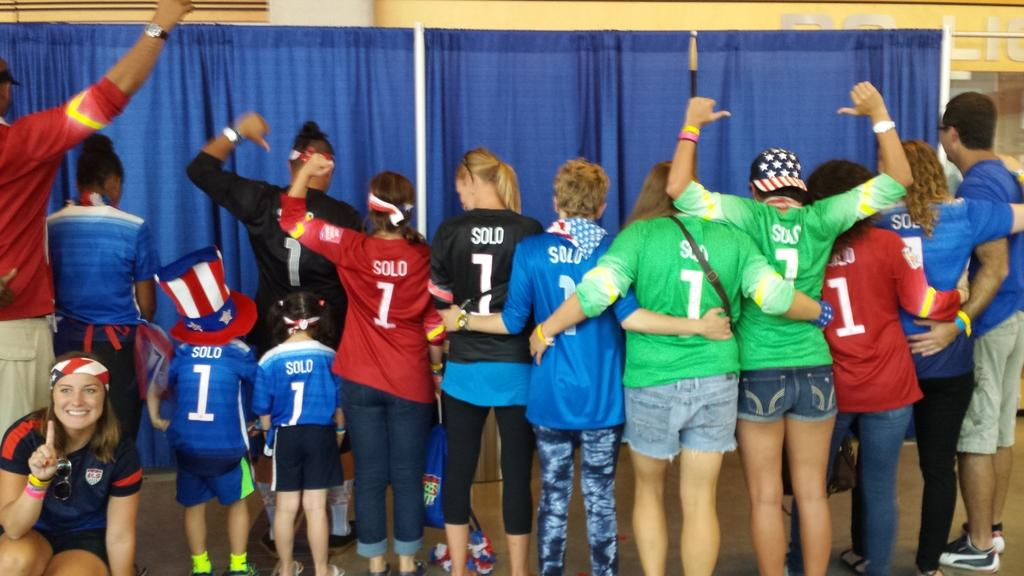<image>
Create a compact narrative representing the image presented. People in varying colors of Solo number 1 jerseys stand with their arms around each other. 